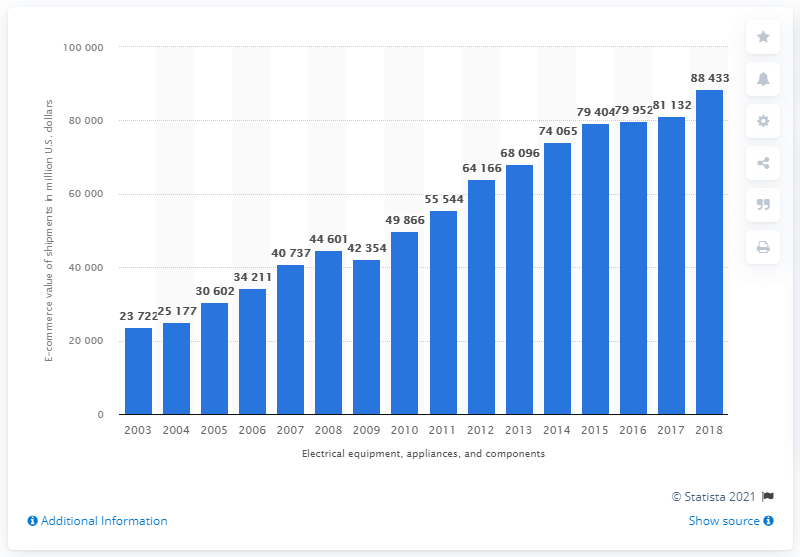Highlight a few significant elements in this photo. In 2018, the value of B2B e-commerce shipments for electrical equipment, appliances, and components manufacturing in the United States was approximately $88,433. The value of electrical equipment, appliance, and component manufacturing shipments in the previous measured period for B2B e-commerce in the category of "What was the B2B e-commerce value of electrical equipment, appliance, and component manufacturing shipments in the previous measured period? 81132.." was $81,132. 